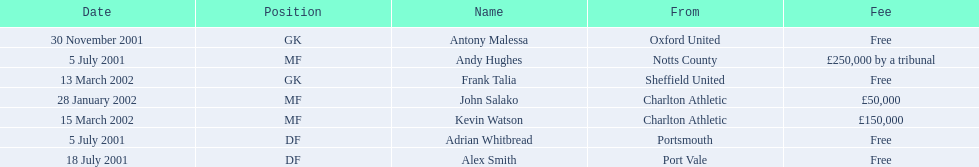What are all of the names? Andy Hughes, Adrian Whitbread, Alex Smith, Antony Malessa, John Salako, Frank Talia, Kevin Watson. What was the fee for each person? £250,000 by a tribunal, Free, Free, Free, £50,000, Free, £150,000. And who had the highest fee? Andy Hughes. 